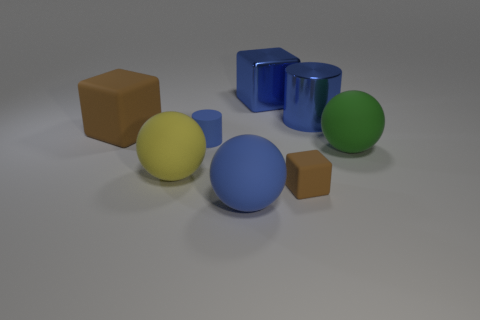Add 1 tiny green rubber cylinders. How many objects exist? 9 Subtract all cylinders. How many objects are left? 6 Subtract all green spheres. Subtract all large blue rubber objects. How many objects are left? 6 Add 3 small objects. How many small objects are left? 5 Add 1 yellow spheres. How many yellow spheres exist? 2 Subtract 0 cyan balls. How many objects are left? 8 